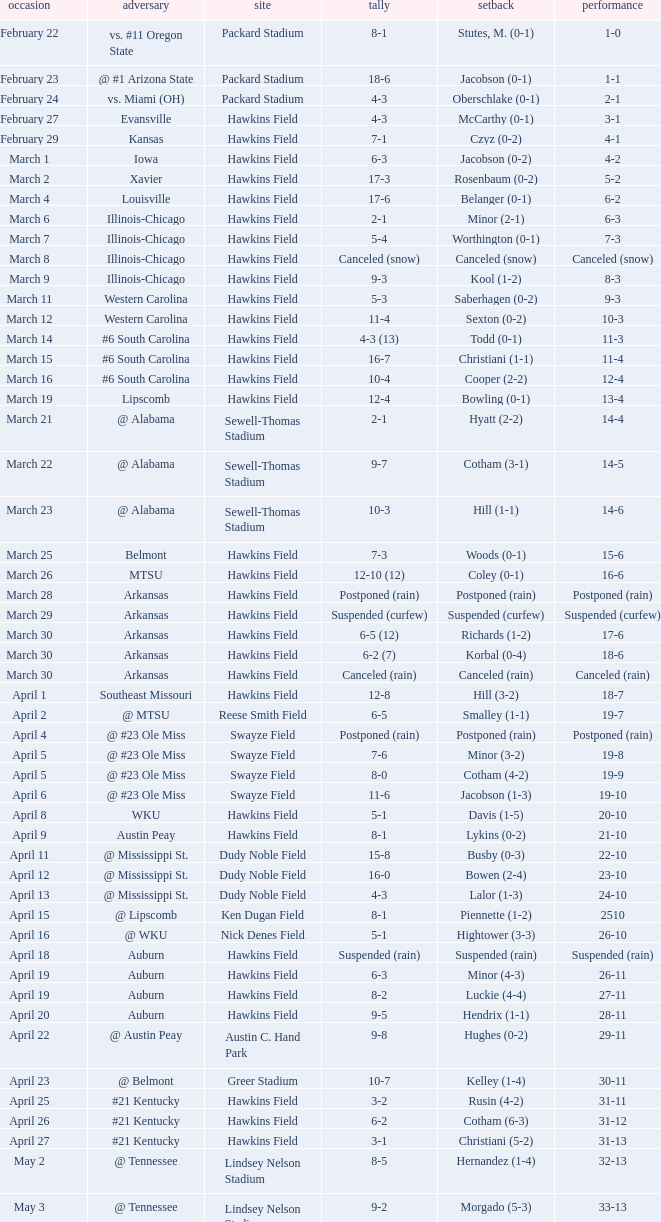What was the location of the game when the record was 12-4? Hawkins Field. 